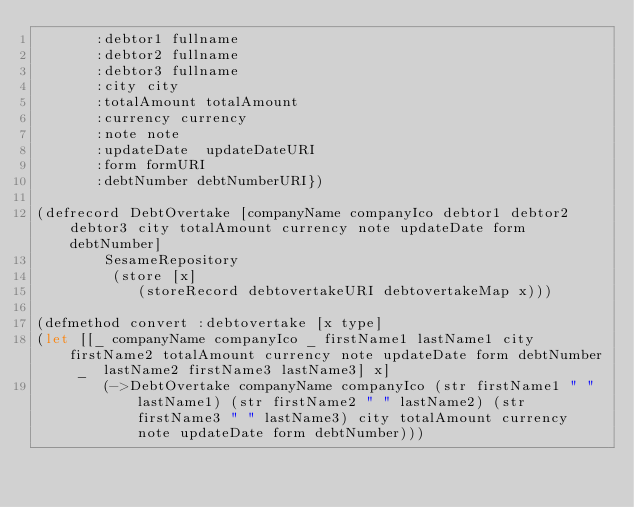Convert code to text. <code><loc_0><loc_0><loc_500><loc_500><_Clojure_>       :debtor1 fullname
       :debtor2 fullname
       :debtor3 fullname
       :city city
       :totalAmount totalAmount 
       :currency currency
       :note note
       :updateDate  updateDateURI
       :form formURI
       :debtNumber debtNumberURI})

(defrecord DebtOvertake [companyName companyIco debtor1 debtor2 debtor3 city totalAmount currency note updateDate form debtNumber]
        SesameRepository
         (store [x]         
            (storeRecord debtovertakeURI debtovertakeMap x)))

(defmethod convert :debtovertake [x type]
(let [[_ companyName companyIco _ firstName1 lastName1 city firstName2 totalAmount currency note updateDate form debtNumber _  lastName2 firstName3 lastName3] x]
        (->DebtOvertake companyName companyIco (str firstName1 " " lastName1) (str firstName2 " " lastName2) (str firstName3 " " lastName3) city totalAmount currency note updateDate form debtNumber)))

</code> 